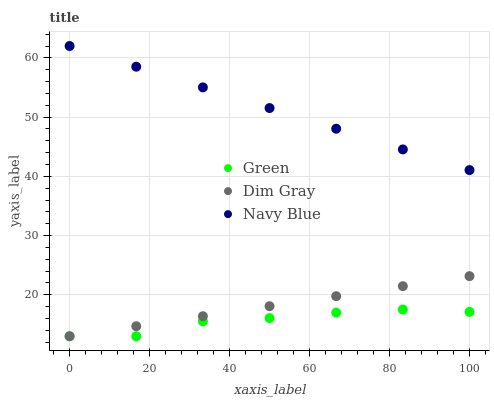Does Green have the minimum area under the curve?
Answer yes or no. Yes. Does Navy Blue have the maximum area under the curve?
Answer yes or no. Yes. Does Dim Gray have the minimum area under the curve?
Answer yes or no. No. Does Dim Gray have the maximum area under the curve?
Answer yes or no. No. Is Navy Blue the smoothest?
Answer yes or no. Yes. Is Green the roughest?
Answer yes or no. Yes. Is Dim Gray the smoothest?
Answer yes or no. No. Is Dim Gray the roughest?
Answer yes or no. No. Does Dim Gray have the lowest value?
Answer yes or no. Yes. Does Navy Blue have the highest value?
Answer yes or no. Yes. Does Dim Gray have the highest value?
Answer yes or no. No. Is Green less than Navy Blue?
Answer yes or no. Yes. Is Navy Blue greater than Dim Gray?
Answer yes or no. Yes. Does Green intersect Dim Gray?
Answer yes or no. Yes. Is Green less than Dim Gray?
Answer yes or no. No. Is Green greater than Dim Gray?
Answer yes or no. No. Does Green intersect Navy Blue?
Answer yes or no. No. 